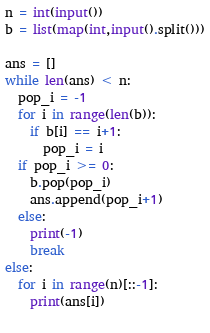<code> <loc_0><loc_0><loc_500><loc_500><_Python_>n = int(input())
b = list(map(int,input().split()))

ans = []
while len(ans) < n:
  pop_i = -1
  for i in range(len(b)):
    if b[i] == i+1:
      pop_i = i
  if pop_i >= 0:
    b.pop(pop_i)
    ans.append(pop_i+1)
  else:
    print(-1)
    break
else:
  for i in range(n)[::-1]:
    print(ans[i])
               </code> 